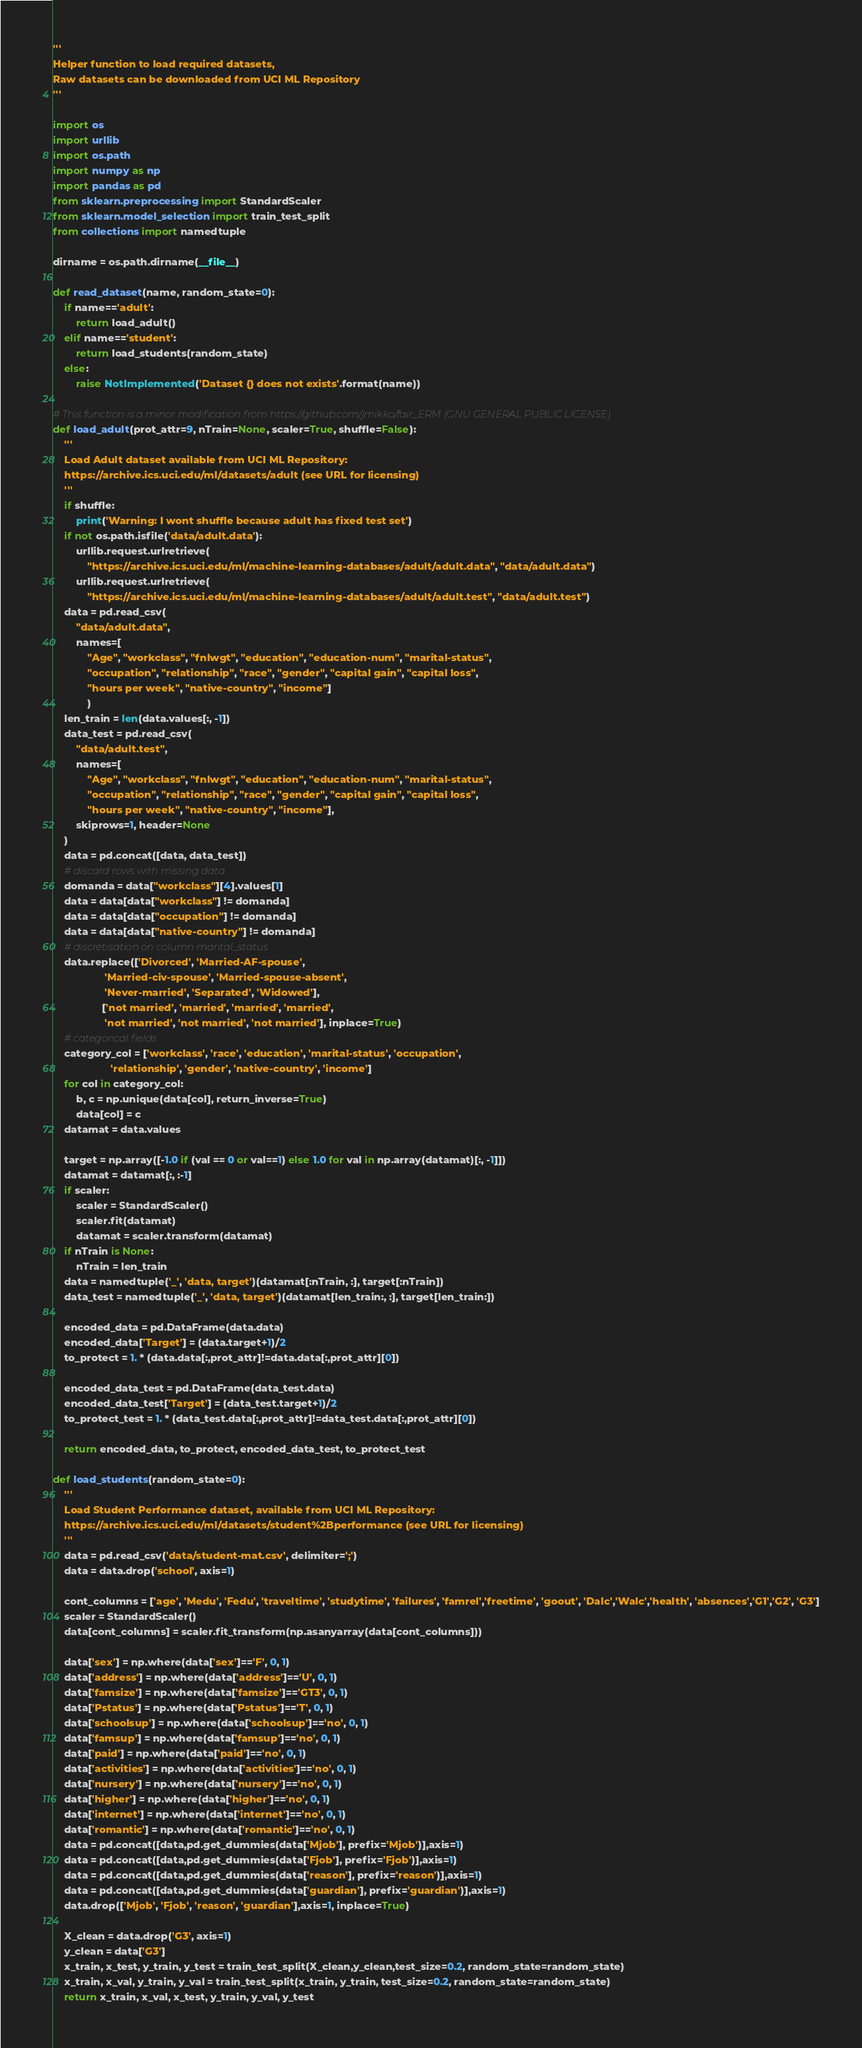Convert code to text. <code><loc_0><loc_0><loc_500><loc_500><_Python_>'''
Helper function to load required datasets,
Raw datasets can be downloaded from UCI ML Repository
'''

import os
import urllib
import os.path
import numpy as np
import pandas as pd
from sklearn.preprocessing import StandardScaler
from sklearn.model_selection import train_test_split
from collections import namedtuple

dirname = os.path.dirname(__file__)

def read_dataset(name, random_state=0):
    if name=='adult':
        return load_adult()
    elif name=='student':
        return load_students(random_state)
    else:
        raise NotImplemented('Dataset {} does not exists'.format(name))

# This function is a minor modification from https://github.com/jmikko/fair_ERM (GNU GENERAL PUBLIC LICENSE)
def load_adult(prot_attr=9, nTrain=None, scaler=True, shuffle=False):
    '''
    Load Adult dataset available from UCI ML Repository:
    https://archive.ics.uci.edu/ml/datasets/adult (see URL for licensing)
    '''
    if shuffle:
        print('Warning: I wont shuffle because adult has fixed test set')
    if not os.path.isfile('data/adult.data'):
        urllib.request.urlretrieve(
            "https://archive.ics.uci.edu/ml/machine-learning-databases/adult/adult.data", "data/adult.data")
        urllib.request.urlretrieve(
            "https://archive.ics.uci.edu/ml/machine-learning-databases/adult/adult.test", "data/adult.test")
    data = pd.read_csv(
        "data/adult.data",
        names=[
            "Age", "workclass", "fnlwgt", "education", "education-num", "marital-status",
            "occupation", "relationship", "race", "gender", "capital gain", "capital loss",
            "hours per week", "native-country", "income"]
            )
    len_train = len(data.values[:, -1])
    data_test = pd.read_csv(
        "data/adult.test",
        names=[
            "Age", "workclass", "fnlwgt", "education", "education-num", "marital-status",
            "occupation", "relationship", "race", "gender", "capital gain", "capital loss",
            "hours per week", "native-country", "income"],
        skiprows=1, header=None
    )
    data = pd.concat([data, data_test])
    # discard rows with missing data
    domanda = data["workclass"][4].values[1]
    data = data[data["workclass"] != domanda]
    data = data[data["occupation"] != domanda]
    data = data[data["native-country"] != domanda]
    # discretisation on column marital_status
    data.replace(['Divorced', 'Married-AF-spouse',
                  'Married-civ-spouse', 'Married-spouse-absent',
                  'Never-married', 'Separated', 'Widowed'],
                 ['not married', 'married', 'married', 'married',
                  'not married', 'not married', 'not married'], inplace=True)
    # categorical fields
    category_col = ['workclass', 'race', 'education', 'marital-status', 'occupation',
                    'relationship', 'gender', 'native-country', 'income']
    for col in category_col:
        b, c = np.unique(data[col], return_inverse=True)
        data[col] = c
    datamat = data.values

    target = np.array([-1.0 if (val == 0 or val==1) else 1.0 for val in np.array(datamat)[:, -1]])
    datamat = datamat[:, :-1]
    if scaler:
        scaler = StandardScaler()
        scaler.fit(datamat)
        datamat = scaler.transform(datamat)
    if nTrain is None:
        nTrain = len_train
    data = namedtuple('_', 'data, target')(datamat[:nTrain, :], target[:nTrain])
    data_test = namedtuple('_', 'data, target')(datamat[len_train:, :], target[len_train:])

    encoded_data = pd.DataFrame(data.data)
    encoded_data['Target'] = (data.target+1)/2
    to_protect = 1. * (data.data[:,prot_attr]!=data.data[:,prot_attr][0])

    encoded_data_test = pd.DataFrame(data_test.data)
    encoded_data_test['Target'] = (data_test.target+1)/2
    to_protect_test = 1. * (data_test.data[:,prot_attr]!=data_test.data[:,prot_attr][0])

    return encoded_data, to_protect, encoded_data_test, to_protect_test

def load_students(random_state=0):
    '''
    Load Student Performance dataset, available from UCI ML Repository:
    https://archive.ics.uci.edu/ml/datasets/student%2Bperformance (see URL for licensing)
    '''
    data = pd.read_csv('data/student-mat.csv', delimiter=';')
    data = data.drop('school', axis=1)

    cont_columns = ['age', 'Medu', 'Fedu', 'traveltime', 'studytime', 'failures', 'famrel','freetime', 'goout', 'Dalc','Walc','health', 'absences','G1','G2', 'G3']
    scaler = StandardScaler()
    data[cont_columns] = scaler.fit_transform(np.asanyarray(data[cont_columns]))

    data['sex'] = np.where(data['sex']=='F', 0, 1)
    data['address'] = np.where(data['address']=='U', 0, 1)
    data['famsize'] = np.where(data['famsize']=='GT3', 0, 1)
    data['Pstatus'] = np.where(data['Pstatus']=='T', 0, 1)
    data['schoolsup'] = np.where(data['schoolsup']=='no', 0, 1)
    data['famsup'] = np.where(data['famsup']=='no', 0, 1)
    data['paid'] = np.where(data['paid']=='no', 0, 1)
    data['activities'] = np.where(data['activities']=='no', 0, 1)
    data['nursery'] = np.where(data['nursery']=='no', 0, 1)
    data['higher'] = np.where(data['higher']=='no', 0, 1)
    data['internet'] = np.where(data['internet']=='no', 0, 1)
    data['romantic'] = np.where(data['romantic']=='no', 0, 1)
    data = pd.concat([data,pd.get_dummies(data['Mjob'], prefix='Mjob')],axis=1)
    data = pd.concat([data,pd.get_dummies(data['Fjob'], prefix='Fjob')],axis=1)
    data = pd.concat([data,pd.get_dummies(data['reason'], prefix='reason')],axis=1)
    data = pd.concat([data,pd.get_dummies(data['guardian'], prefix='guardian')],axis=1)
    data.drop(['Mjob', 'Fjob', 'reason', 'guardian'],axis=1, inplace=True)

    X_clean = data.drop('G3', axis=1)
    y_clean = data['G3']
    x_train, x_test, y_train, y_test = train_test_split(X_clean,y_clean,test_size=0.2, random_state=random_state)
    x_train, x_val, y_train, y_val = train_test_split(x_train, y_train, test_size=0.2, random_state=random_state)
    return x_train, x_val, x_test, y_train, y_val, y_test
</code> 